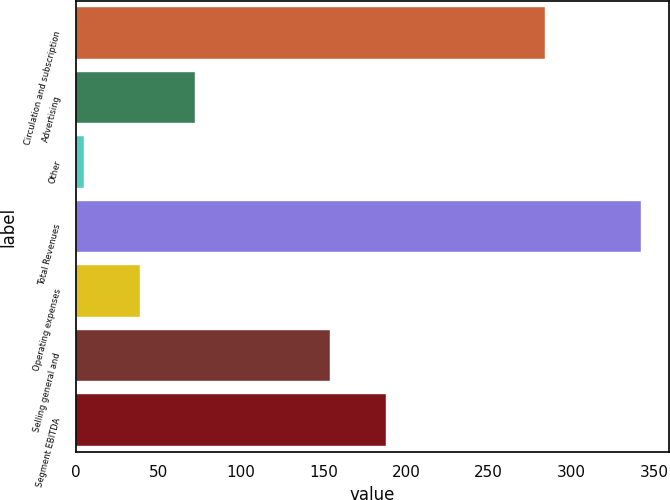<chart> <loc_0><loc_0><loc_500><loc_500><bar_chart><fcel>Circulation and subscription<fcel>Advertising<fcel>Other<fcel>Total Revenues<fcel>Operating expenses<fcel>Selling general and<fcel>Segment EBITDA<nl><fcel>284<fcel>72.4<fcel>5<fcel>342<fcel>38.7<fcel>154<fcel>187.7<nl></chart> 